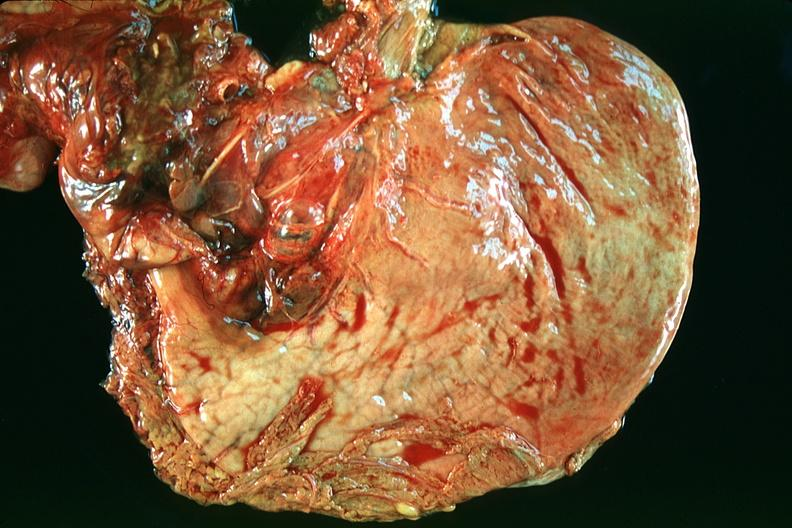what does this image show?
Answer the question using a single word or phrase. Normal stomach 